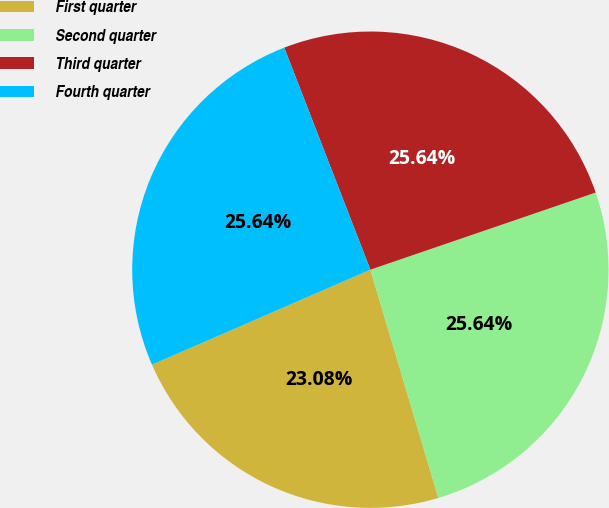<chart> <loc_0><loc_0><loc_500><loc_500><pie_chart><fcel>First quarter<fcel>Second quarter<fcel>Third quarter<fcel>Fourth quarter<nl><fcel>23.08%<fcel>25.64%<fcel>25.64%<fcel>25.64%<nl></chart> 